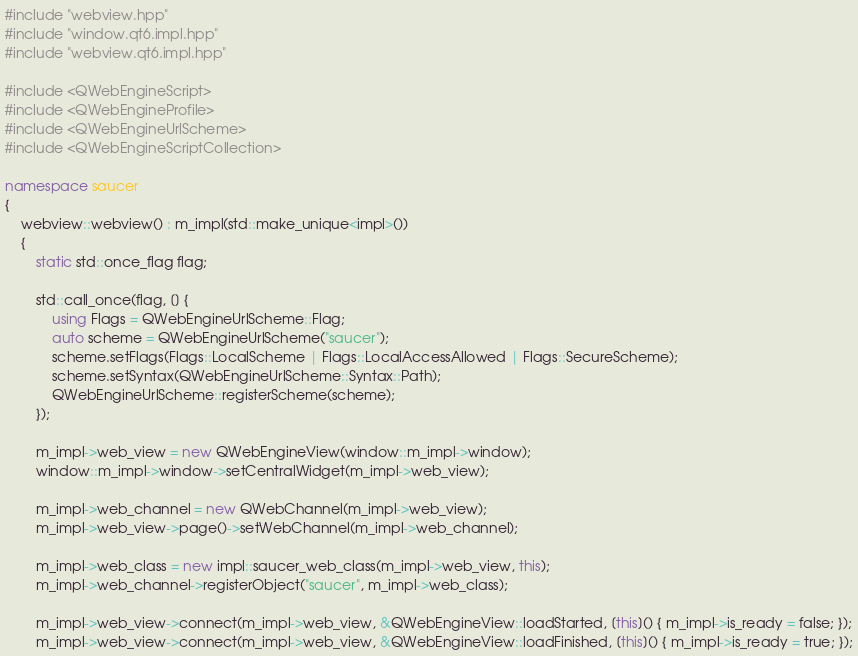Convert code to text. <code><loc_0><loc_0><loc_500><loc_500><_C++_>#include "webview.hpp"
#include "window.qt6.impl.hpp"
#include "webview.qt6.impl.hpp"

#include <QWebEngineScript>
#include <QWebEngineProfile>
#include <QWebEngineUrlScheme>
#include <QWebEngineScriptCollection>

namespace saucer
{
    webview::webview() : m_impl(std::make_unique<impl>())
    {
        static std::once_flag flag;

        std::call_once(flag, [] {
            using Flags = QWebEngineUrlScheme::Flag;
            auto scheme = QWebEngineUrlScheme("saucer");
            scheme.setFlags(Flags::LocalScheme | Flags::LocalAccessAllowed | Flags::SecureScheme);
            scheme.setSyntax(QWebEngineUrlScheme::Syntax::Path);
            QWebEngineUrlScheme::registerScheme(scheme);
        });

        m_impl->web_view = new QWebEngineView(window::m_impl->window);
        window::m_impl->window->setCentralWidget(m_impl->web_view);

        m_impl->web_channel = new QWebChannel(m_impl->web_view);
        m_impl->web_view->page()->setWebChannel(m_impl->web_channel);

        m_impl->web_class = new impl::saucer_web_class(m_impl->web_view, this);
        m_impl->web_channel->registerObject("saucer", m_impl->web_class);

        m_impl->web_view->connect(m_impl->web_view, &QWebEngineView::loadStarted, [this]() { m_impl->is_ready = false; });
        m_impl->web_view->connect(m_impl->web_view, &QWebEngineView::loadFinished, [this]() { m_impl->is_ready = true; });</code> 